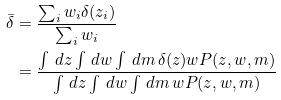<formula> <loc_0><loc_0><loc_500><loc_500>\bar { \delta } & = \frac { \sum _ { i } w _ { i } \delta ( z _ { i } ) } { \sum _ { i } w _ { i } } \\ & = \frac { \int \, d z \int \, d w \int \, d m \, \delta ( z ) w P ( z , w , m ) } { \int \, d z \int \, d w \int \, d m \, w P ( z , w , m ) }</formula> 